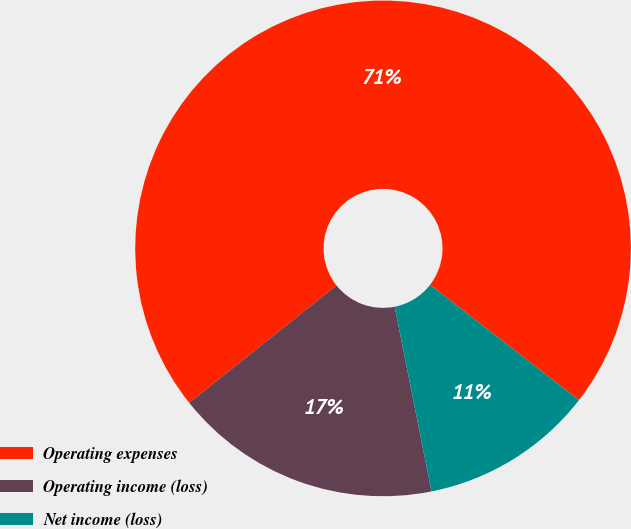Convert chart. <chart><loc_0><loc_0><loc_500><loc_500><pie_chart><fcel>Operating expenses<fcel>Operating income (loss)<fcel>Net income (loss)<nl><fcel>71.19%<fcel>17.43%<fcel>11.38%<nl></chart> 